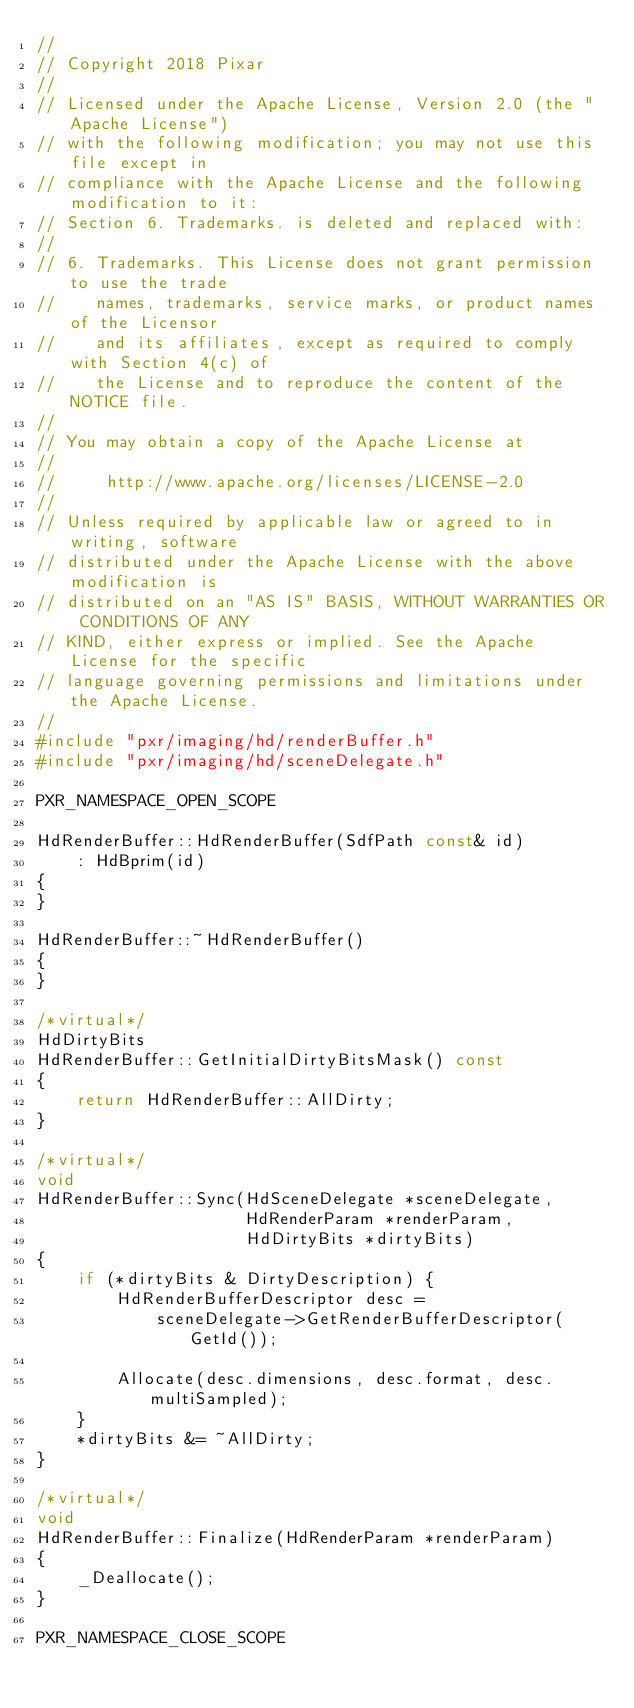Convert code to text. <code><loc_0><loc_0><loc_500><loc_500><_C++_>//
// Copyright 2018 Pixar
//
// Licensed under the Apache License, Version 2.0 (the "Apache License")
// with the following modification; you may not use this file except in
// compliance with the Apache License and the following modification to it:
// Section 6. Trademarks. is deleted and replaced with:
//
// 6. Trademarks. This License does not grant permission to use the trade
//    names, trademarks, service marks, or product names of the Licensor
//    and its affiliates, except as required to comply with Section 4(c) of
//    the License and to reproduce the content of the NOTICE file.
//
// You may obtain a copy of the Apache License at
//
//     http://www.apache.org/licenses/LICENSE-2.0
//
// Unless required by applicable law or agreed to in writing, software
// distributed under the Apache License with the above modification is
// distributed on an "AS IS" BASIS, WITHOUT WARRANTIES OR CONDITIONS OF ANY
// KIND, either express or implied. See the Apache License for the specific
// language governing permissions and limitations under the Apache License.
//
#include "pxr/imaging/hd/renderBuffer.h"
#include "pxr/imaging/hd/sceneDelegate.h"

PXR_NAMESPACE_OPEN_SCOPE

HdRenderBuffer::HdRenderBuffer(SdfPath const& id)
    : HdBprim(id)
{
}

HdRenderBuffer::~HdRenderBuffer()
{
}

/*virtual*/
HdDirtyBits
HdRenderBuffer::GetInitialDirtyBitsMask() const
{
    return HdRenderBuffer::AllDirty;
}

/*virtual*/
void
HdRenderBuffer::Sync(HdSceneDelegate *sceneDelegate,
                     HdRenderParam *renderParam,
                     HdDirtyBits *dirtyBits)
{
    if (*dirtyBits & DirtyDescription) {
        HdRenderBufferDescriptor desc =
            sceneDelegate->GetRenderBufferDescriptor(GetId());

        Allocate(desc.dimensions, desc.format, desc.multiSampled);
    }
    *dirtyBits &= ~AllDirty;
}

/*virtual*/
void
HdRenderBuffer::Finalize(HdRenderParam *renderParam)
{
    _Deallocate();
}

PXR_NAMESPACE_CLOSE_SCOPE
</code> 